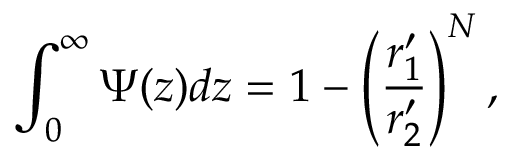Convert formula to latex. <formula><loc_0><loc_0><loc_500><loc_500>\int _ { 0 } ^ { \infty } \Psi ( z ) d z = 1 - \left ( \frac { r _ { 1 } ^ { \prime } } { r _ { 2 } ^ { \prime } } \right ) ^ { N } ,</formula> 